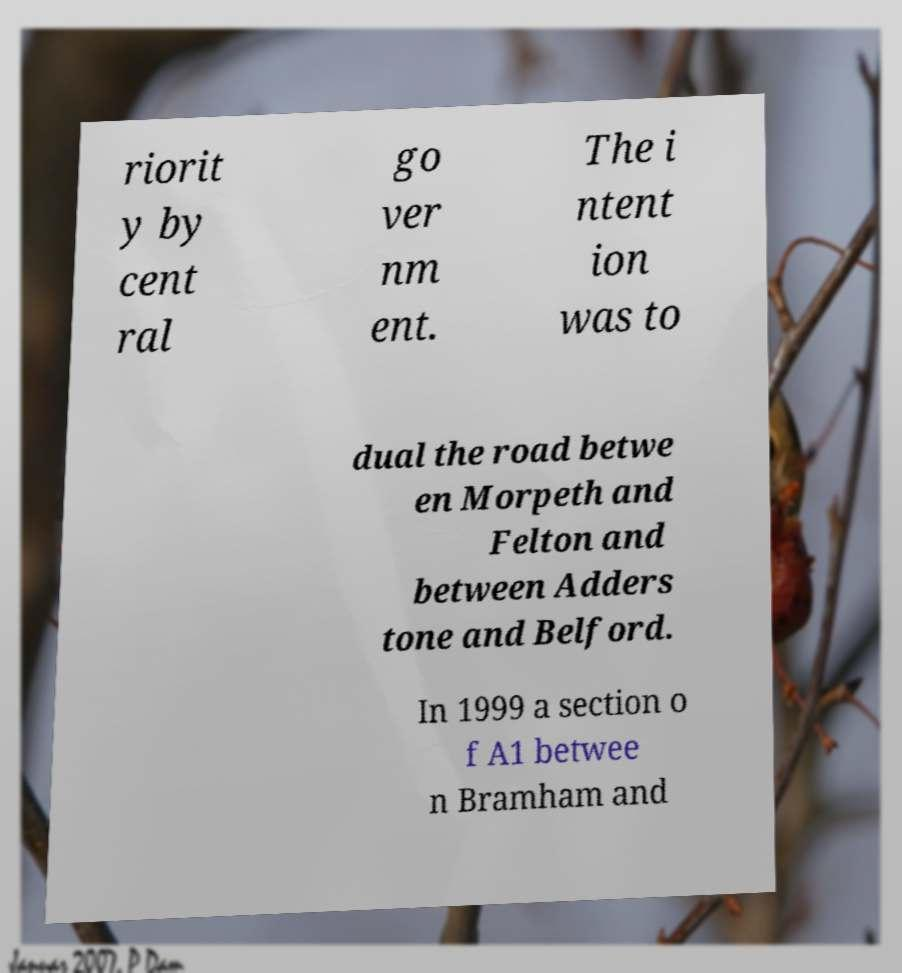There's text embedded in this image that I need extracted. Can you transcribe it verbatim? riorit y by cent ral go ver nm ent. The i ntent ion was to dual the road betwe en Morpeth and Felton and between Adders tone and Belford. In 1999 a section o f A1 betwee n Bramham and 